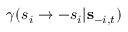<formula> <loc_0><loc_0><loc_500><loc_500>\gamma ( s _ { i } \to - s _ { i } | { s } _ { - i , t } )</formula> 